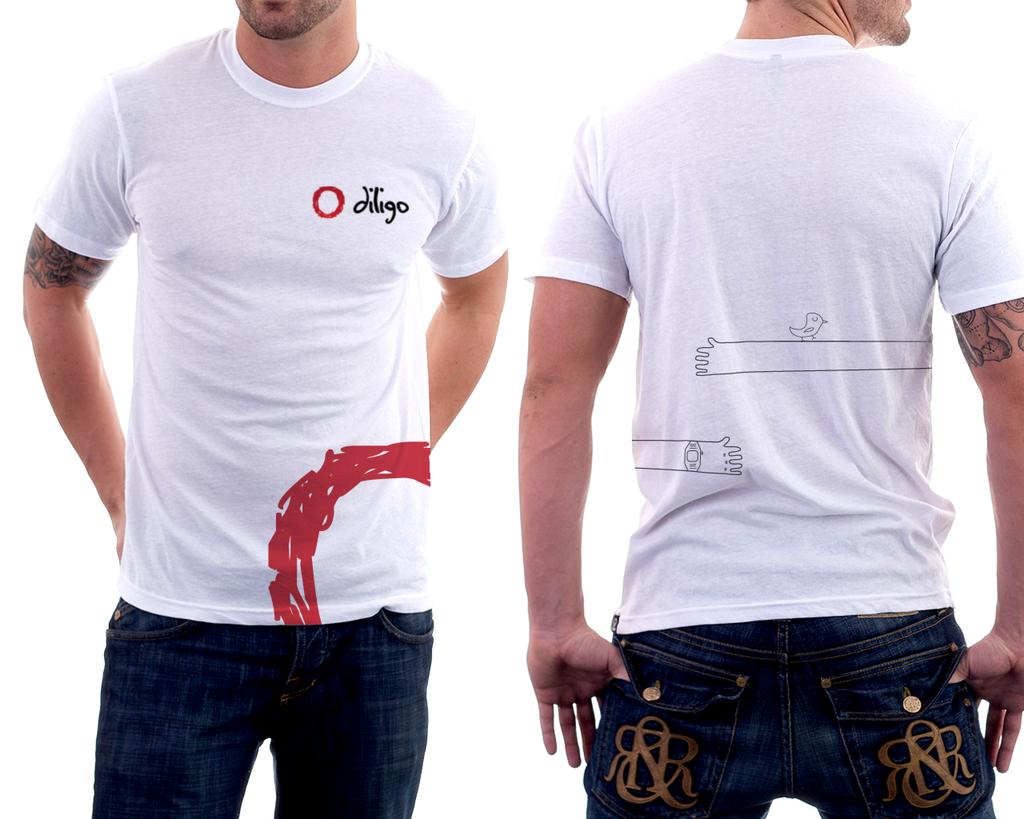How many people are in the image? There are two people in the image. What can be observed on the people's bodies? The people have tattoos. What is the color of the background in the image? The background of the image is white. What type of plants can be seen growing in the quicksand in the image? There is no quicksand or plants present in the image. 